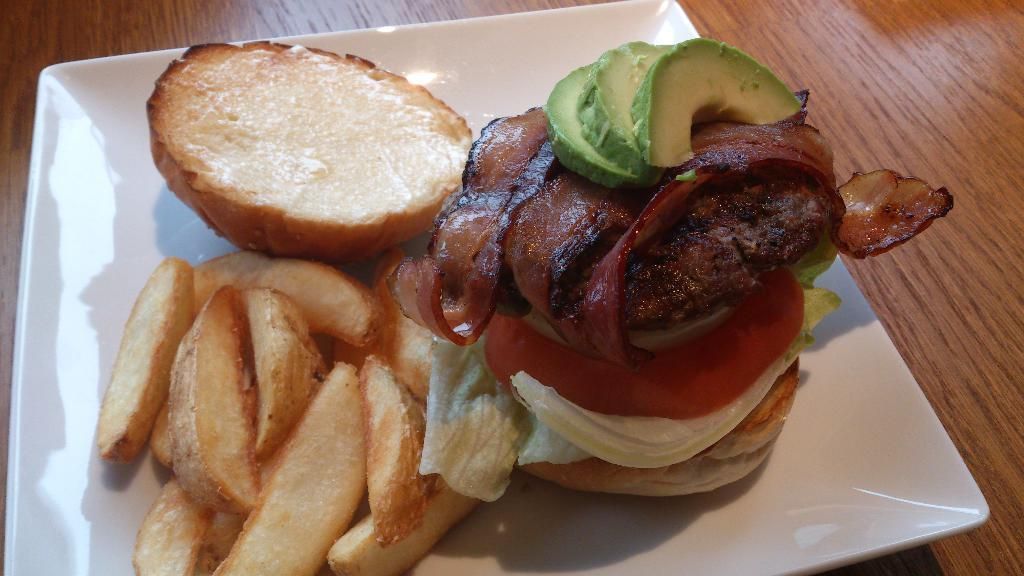What is on the plate in the image? There are food items on a plate in the image. What color is the plate? The plate is white. Where is the plate located in the image? The plate is placed on a table. What type of engine can be seen powering the food items on the plate? There is no engine present in the image, and the food items are not powered by any engine. 